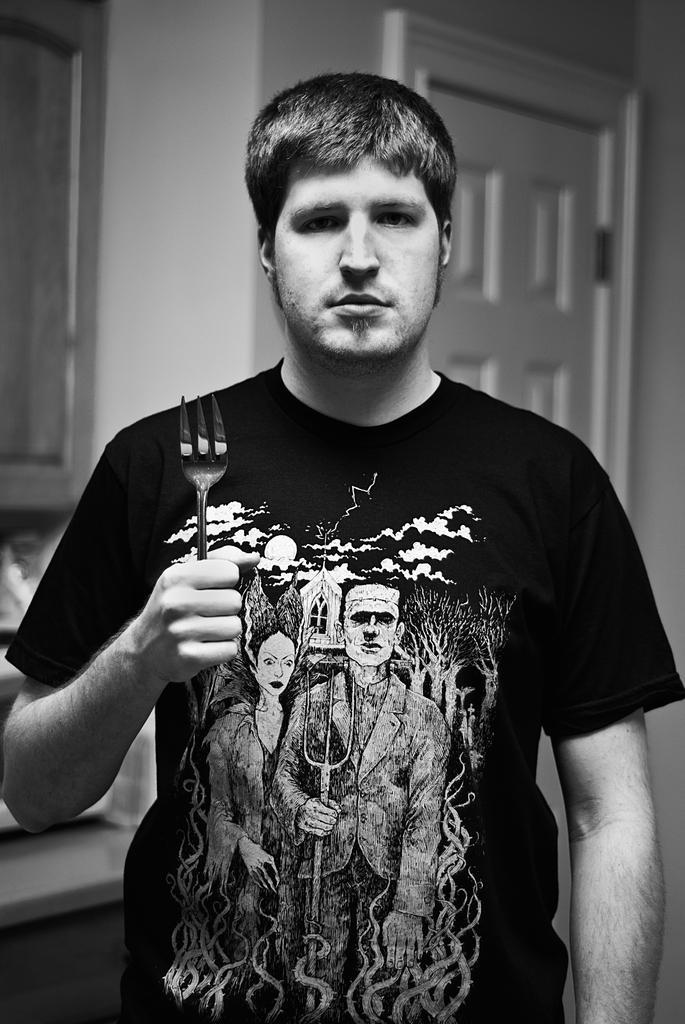Can you describe this image briefly? In the image a man is standing wearing a black t-shirt. He is holding a fork. In the background there is window and cupboard. 